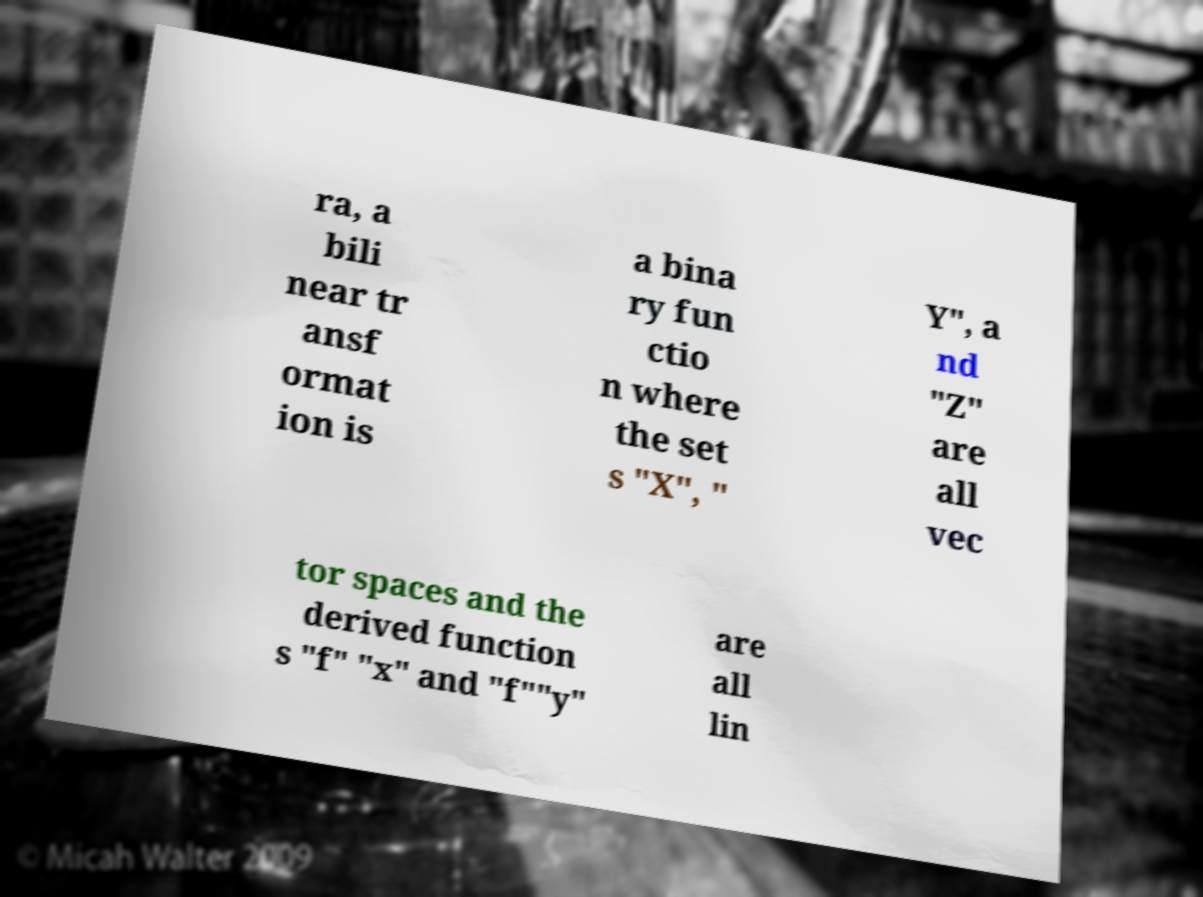For documentation purposes, I need the text within this image transcribed. Could you provide that? ra, a bili near tr ansf ormat ion is a bina ry fun ctio n where the set s "X", " Y", a nd "Z" are all vec tor spaces and the derived function s "f" "x" and "f""y" are all lin 